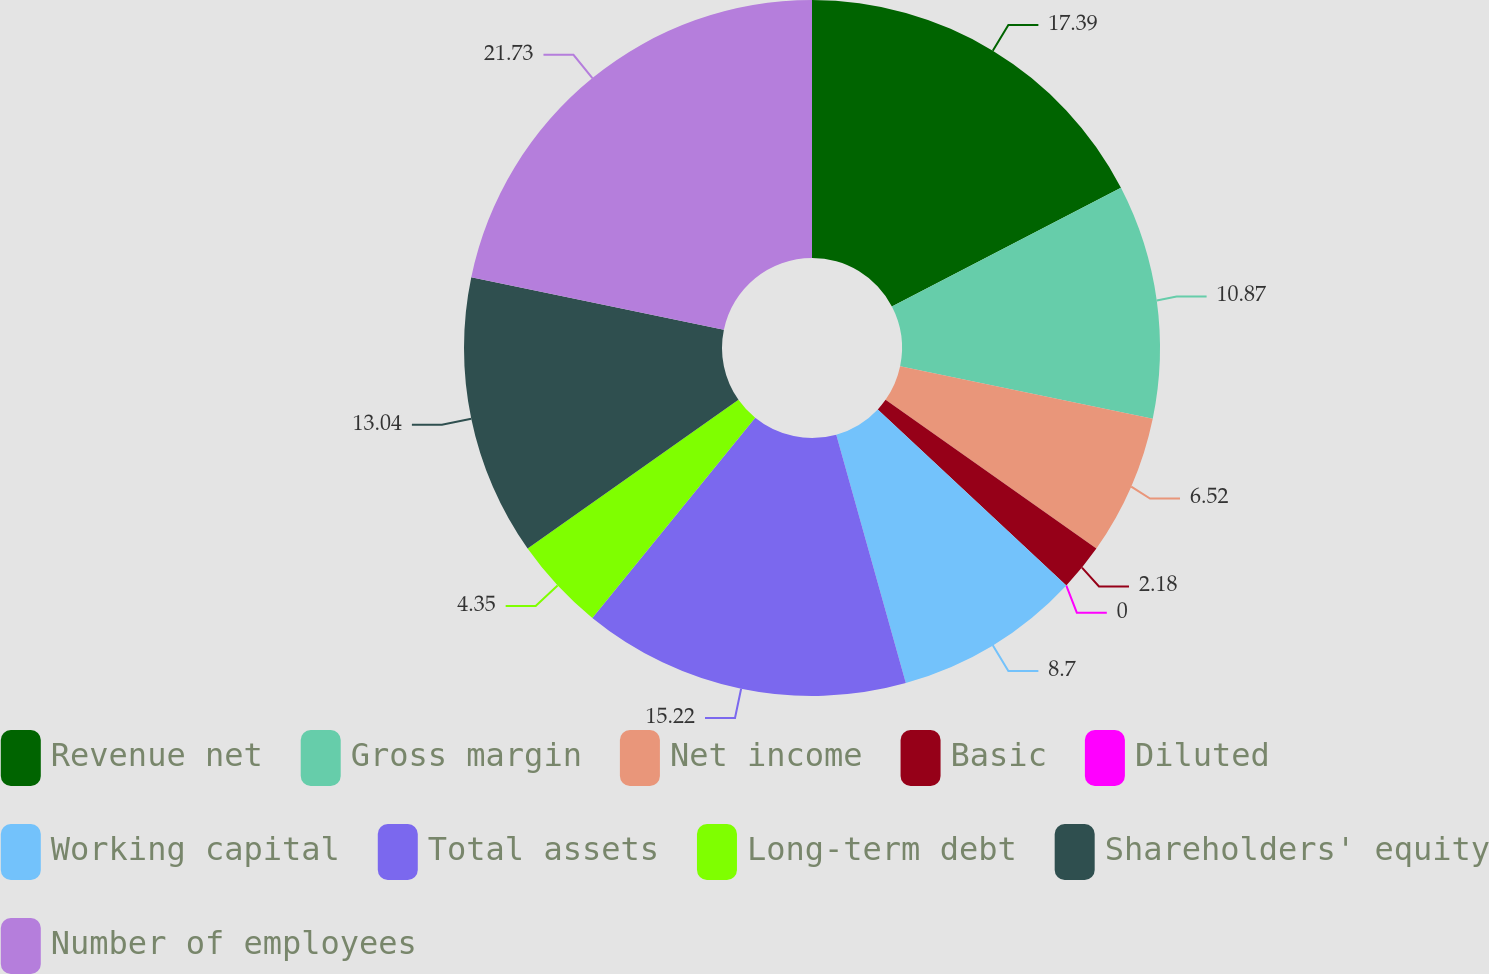Convert chart to OTSL. <chart><loc_0><loc_0><loc_500><loc_500><pie_chart><fcel>Revenue net<fcel>Gross margin<fcel>Net income<fcel>Basic<fcel>Diluted<fcel>Working capital<fcel>Total assets<fcel>Long-term debt<fcel>Shareholders' equity<fcel>Number of employees<nl><fcel>17.39%<fcel>10.87%<fcel>6.52%<fcel>2.18%<fcel>0.0%<fcel>8.7%<fcel>15.22%<fcel>4.35%<fcel>13.04%<fcel>21.74%<nl></chart> 